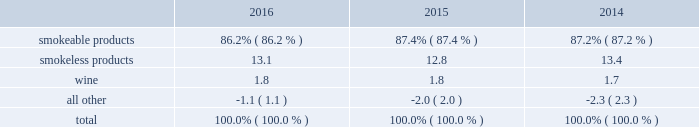The relative percentages of operating companies income ( loss ) attributable to each reportable segment and the all other category were as follows: .
For items affecting the comparability of the relative percentages of operating companies income ( loss ) attributable to each reportable segment , see note 16 .
Narrative description of business portions of the information called for by this item are included in operating results by business segment in item 7 .
Management 2019s discussion and analysis of financial condition and results of operations of this annual report on form 10-k ( 201citem 7 201d ) .
Tobacco space altria group , inc . 2019s tobacco operating companies include pm usa , usstc and other subsidiaries of ust , middleton , nu mark and nat sherman .
Altria group distribution company provides sales , distribution and consumer engagement services to altria group , inc . 2019s tobacco operating companies .
The products of altria group , inc . 2019s tobacco subsidiaries include smokeable tobacco products , consisting of cigarettes manufactured and sold by pm usa and nat sherman , machine- made large cigars and pipe tobacco manufactured and sold by middleton and premium cigars sold by nat sherman ; smokeless tobacco products manufactured and sold by usstc ; and innovative tobacco products , including e-vapor products manufactured and sold by nu mark .
Cigarettes : pm usa is the largest cigarette company in the united states , with total cigarette shipment volume in the united states of approximately 122.9 billion units in 2016 , a decrease of 2.5% ( 2.5 % ) from 2015 .
Marlboro , the principal cigarette brand of pm usa , has been the largest-selling cigarette brand in the united states for over 40 years .
Nat sherman sells substantially all of its super-premium cigarettes in the united states .
Cigars : middleton is engaged in the manufacture and sale of machine-made large cigars and pipe tobacco to customers , substantially all of which are located in the united states .
Middleton sources a portion of its cigars from an importer through a third-party contract manufacturing arrangement .
Total shipment volume for cigars was approximately 1.4 billion units in 2016 , an increase of 5.9% ( 5.9 % ) from 2015 .
Black & mild is the principal cigar brand of middleton .
Nat sherman sources its premium cigars from importers through third-party contract manufacturing arrangements and sells substantially all of its cigars in the united states .
Smokeless tobacco products : usstc is the leading producer and marketer of moist smokeless tobacco ( 201cmst 201d ) products .
The smokeless products segment includes the premium brands , copenhagen and skoal , and value brands , red seal and husky .
Substantially all of the smokeless tobacco products are manufactured and sold to customers in the united states .
Total smokeless products shipment volume was 853.5 million units in 2016 , an increase of 4.9% ( 4.9 % ) from 2015 .
Innovative tobacco products : nu mark participates in the e-vapor category and has developed and commercialized other innovative tobacco products .
In addition , nu mark sources the production of its e-vapor products through overseas contract manufacturing arrangements .
In 2013 , nu mark introduced markten e-vapor products .
In april 2014 , nu mark acquired the e-vapor business of green smoke , inc .
And its affiliates ( 201cgreen smoke 201d ) , which began selling e-vapor products in 2009 .
For a further discussion of the acquisition of green smoke , see note 3 .
Acquisition of green smoke to the consolidated financial statements in item 8 ( 201cnote 3 201d ) .
In december 2013 , altria group , inc . 2019s subsidiaries entered into a series of agreements with philip morris international inc .
( 201cpmi 201d ) pursuant to which altria group , inc . 2019s subsidiaries provide an exclusive license to pmi to sell nu mark 2019s e-vapor products outside the united states , and pmi 2019s subsidiaries provide an exclusive license to altria group , inc . 2019s subsidiaries to sell two of pmi 2019s heated tobacco product platforms in the united states .
Further , in july 2015 , altria group , inc .
Announced the expansion of its strategic framework with pmi to include a joint research , development and technology-sharing agreement .
Under this agreement , altria group , inc . 2019s subsidiaries and pmi will collaborate to develop e-vapor products for commercialization in the united states by altria group , inc . 2019s subsidiaries and in markets outside the united states by pmi .
This agreement also provides for exclusive technology cross licenses , technical information sharing and cooperation on scientific assessment , regulatory engagement and approval related to e-vapor products .
In the fourth quarter of 2016 , pmi submitted a modified risk tobacco product ( 201cmrtp 201d ) application for an electronically heated tobacco product with the united states food and drug administration 2019s ( 201cfda 201d ) center for tobacco products and announced that it plans to file its corresponding pre-market tobacco product application during the first quarter of 2017 .
The fda must determine whether to accept the applications for substantive review .
Upon regulatory authorization by the fda , altria group , inc . 2019s subsidiaries will have an exclusive license to sell this heated tobacco product in the united states .
Distribution , competition and raw materials : altria group , inc . 2019s tobacco subsidiaries sell their tobacco products principally to wholesalers ( including distributors ) , large retail organizations , including chain stores , and the armed services .
The market for tobacco products is highly competitive , characterized by brand recognition and loyalty , with product quality , taste , price , product innovation , marketing , packaging and distribution constituting the significant methods of competition .
Promotional activities include , in certain instances and where .
What would total smokeless products shipment volume be in 2017 with the same growth rate as 2016 , in billions? 
Computations: (853.5 + 4.9%)
Answer: 853.549. 